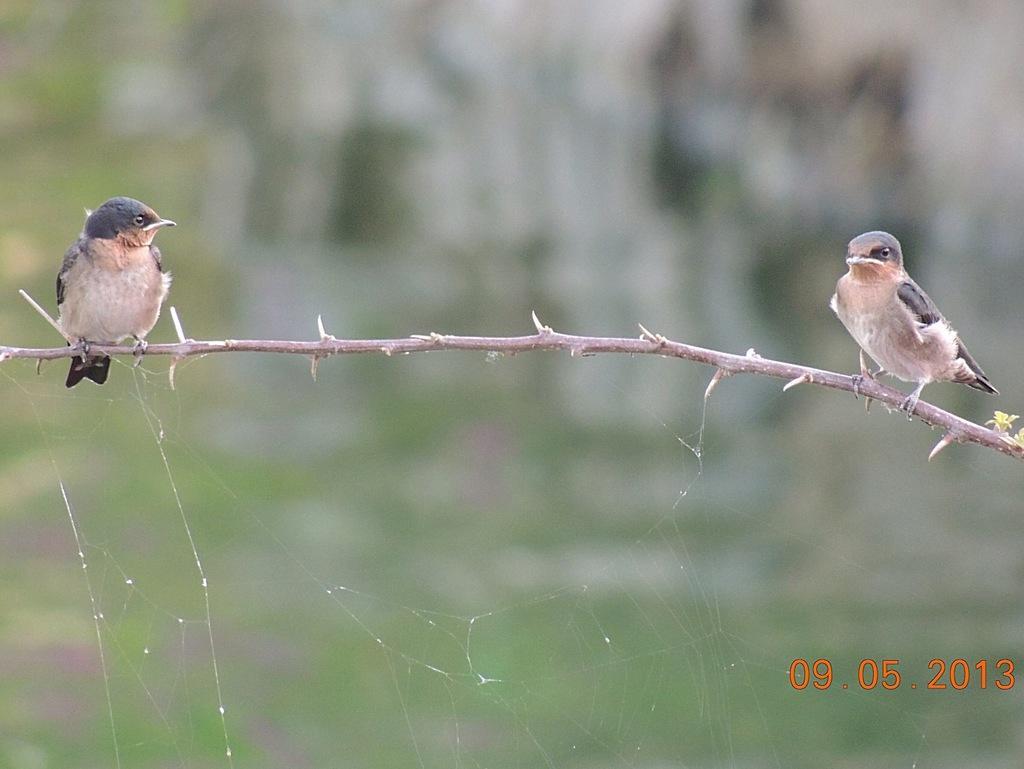In one or two sentences, can you explain what this image depicts? In this image we can see two birds sitting on the stem and we can also see a date at the bottom. 